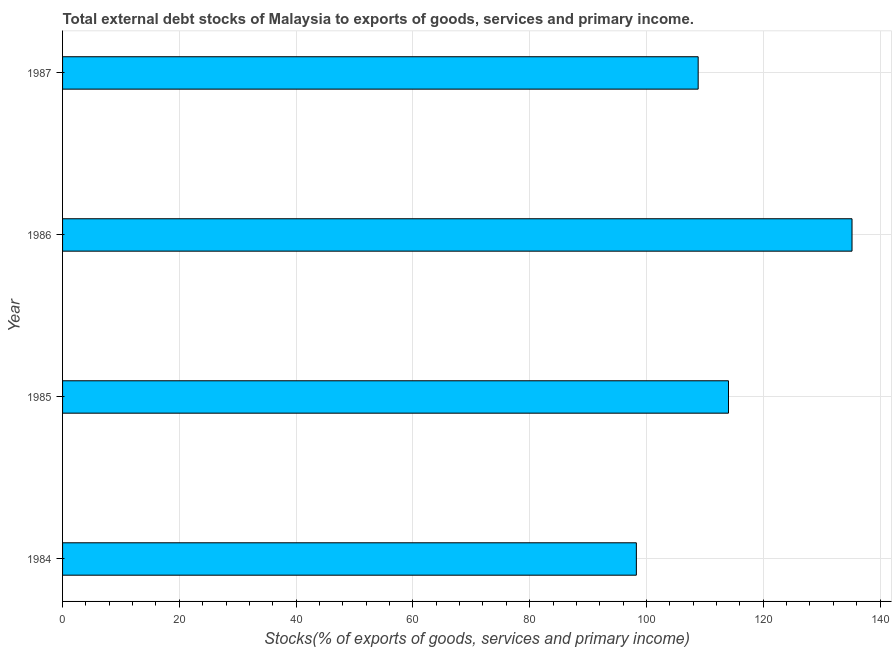Does the graph contain grids?
Give a very brief answer. Yes. What is the title of the graph?
Make the answer very short. Total external debt stocks of Malaysia to exports of goods, services and primary income. What is the label or title of the X-axis?
Your answer should be very brief. Stocks(% of exports of goods, services and primary income). What is the external debt stocks in 1985?
Give a very brief answer. 114.05. Across all years, what is the maximum external debt stocks?
Your response must be concise. 135.21. Across all years, what is the minimum external debt stocks?
Your response must be concise. 98.27. In which year was the external debt stocks maximum?
Make the answer very short. 1986. In which year was the external debt stocks minimum?
Your answer should be compact. 1984. What is the sum of the external debt stocks?
Your answer should be very brief. 456.38. What is the difference between the external debt stocks in 1986 and 1987?
Offer a terse response. 26.35. What is the average external debt stocks per year?
Provide a short and direct response. 114.1. What is the median external debt stocks?
Your response must be concise. 111.45. In how many years, is the external debt stocks greater than 72 %?
Your answer should be very brief. 4. What is the ratio of the external debt stocks in 1984 to that in 1985?
Provide a succinct answer. 0.86. Is the external debt stocks in 1984 less than that in 1987?
Offer a very short reply. Yes. What is the difference between the highest and the second highest external debt stocks?
Your answer should be very brief. 21.16. Is the sum of the external debt stocks in 1985 and 1987 greater than the maximum external debt stocks across all years?
Provide a short and direct response. Yes. What is the difference between the highest and the lowest external debt stocks?
Your answer should be very brief. 36.93. How many years are there in the graph?
Your answer should be very brief. 4. What is the difference between two consecutive major ticks on the X-axis?
Your answer should be very brief. 20. What is the Stocks(% of exports of goods, services and primary income) of 1984?
Offer a terse response. 98.27. What is the Stocks(% of exports of goods, services and primary income) of 1985?
Offer a terse response. 114.05. What is the Stocks(% of exports of goods, services and primary income) in 1986?
Your answer should be very brief. 135.21. What is the Stocks(% of exports of goods, services and primary income) in 1987?
Provide a short and direct response. 108.86. What is the difference between the Stocks(% of exports of goods, services and primary income) in 1984 and 1985?
Offer a terse response. -15.78. What is the difference between the Stocks(% of exports of goods, services and primary income) in 1984 and 1986?
Your answer should be compact. -36.93. What is the difference between the Stocks(% of exports of goods, services and primary income) in 1984 and 1987?
Offer a very short reply. -10.58. What is the difference between the Stocks(% of exports of goods, services and primary income) in 1985 and 1986?
Ensure brevity in your answer.  -21.16. What is the difference between the Stocks(% of exports of goods, services and primary income) in 1985 and 1987?
Your answer should be very brief. 5.19. What is the difference between the Stocks(% of exports of goods, services and primary income) in 1986 and 1987?
Make the answer very short. 26.35. What is the ratio of the Stocks(% of exports of goods, services and primary income) in 1984 to that in 1985?
Your answer should be very brief. 0.86. What is the ratio of the Stocks(% of exports of goods, services and primary income) in 1984 to that in 1986?
Your response must be concise. 0.73. What is the ratio of the Stocks(% of exports of goods, services and primary income) in 1984 to that in 1987?
Offer a very short reply. 0.9. What is the ratio of the Stocks(% of exports of goods, services and primary income) in 1985 to that in 1986?
Your answer should be compact. 0.84. What is the ratio of the Stocks(% of exports of goods, services and primary income) in 1985 to that in 1987?
Offer a terse response. 1.05. What is the ratio of the Stocks(% of exports of goods, services and primary income) in 1986 to that in 1987?
Your response must be concise. 1.24. 